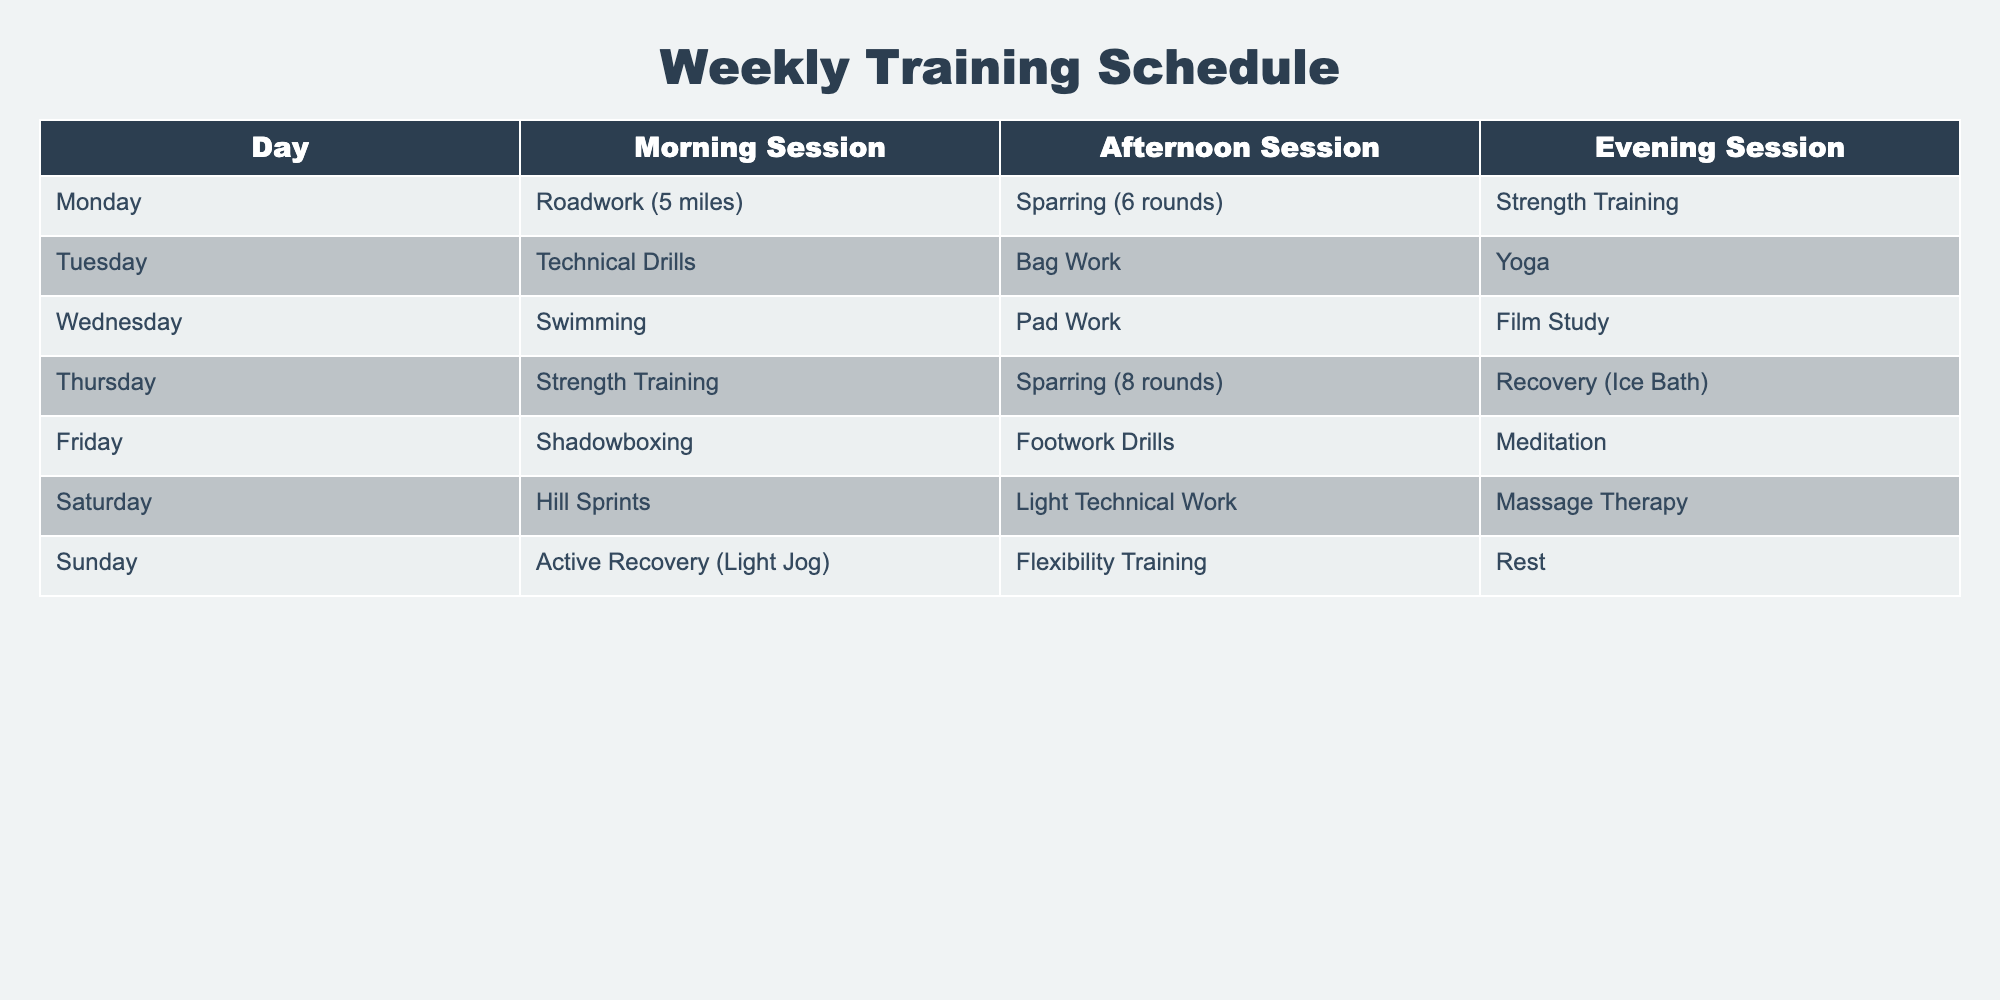What activities are scheduled for Wednesday? By looking at the table, we can see the entries for Wednesday under each session. The morning session is 'Swimming', the afternoon session is 'Pad Work', and the evening session is 'Film Study'.
Answer: Swimming, Pad Work, Film Study How many rounds of sparring are planned on Thursday? The table states that on Thursday, the afternoon session is 'Sparring (8 rounds)'. Thus, the specific number of rounds of sparring is directly mentioned in the schedule.
Answer: 8 rounds Which day features the least amount of structured training? Looking at the table, Sunday lists 'Active Recovery (Light Jog)', 'Flexibility Training', and 'Rest'. 'Rest' indicates no structured training, while the other days include three sessions. This makes Sunday the day with the least structured training overall.
Answer: Sunday How often does strength training occur in the schedule? The table shows strength training scheduled twice throughout the week: once on Monday and once on Thursday. Therefore, the frequency can be determined by counting the occurrences.
Answer: 2 times Does the training schedule include any activities focused on recovery? Checking the table, we can see that 'Recovery (Ice Bath)' is mentioned on Thursday, while 'Active Recovery (Light Jog)' on Sunday also focuses on recovery. Therefore, there are activities that focus on recovery in the schedule.
Answer: Yes What is the total number of activities scheduled on Saturday? On Saturday, the sessions are 'Hill Sprints', 'Light Technical Work', and 'Massage Therapy'. Adding these three activities indicates the total number of different scheduled training activities for that day.
Answer: 3 activities On which day is there a specific focus on yoga? Referring to the table, yoga sessions are outlined exclusively on Tuesday during the evening session. It's clear and distinct from the other days listed.
Answer: Tuesday Which day has a total of 6 rounds of sparring? The table specifies that Monday has 'Sparring (6 rounds)' in the afternoon session. This explicitly provides the information sought regarding sparring rounds.
Answer: Monday What is the morning session activity on Friday compared to that of Tuesday? On Friday, the morning session includes 'Shadowboxing', while Tuesday's morning session features 'Technical Drills'. Comparing these two reveals the distinct activities scheduled in the mornings for each of those days.
Answer: Shadowboxing vs. Technical Drills 